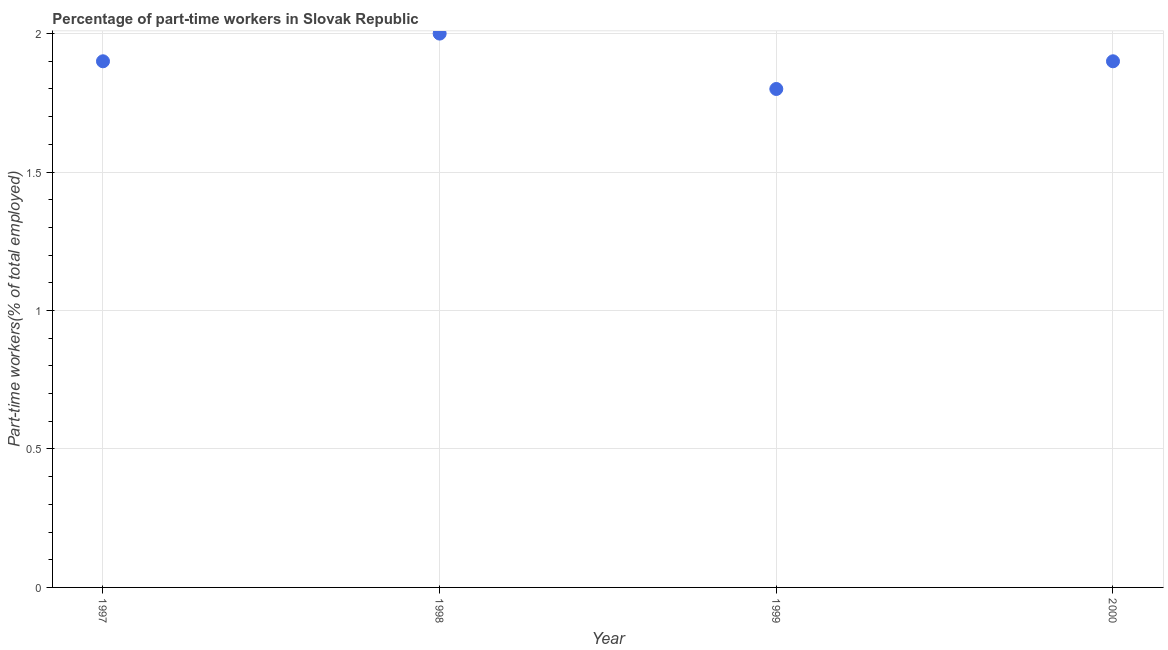What is the percentage of part-time workers in 2000?
Keep it short and to the point. 1.9. Across all years, what is the maximum percentage of part-time workers?
Your answer should be compact. 2. Across all years, what is the minimum percentage of part-time workers?
Your answer should be very brief. 1.8. What is the sum of the percentage of part-time workers?
Your response must be concise. 7.6. What is the difference between the percentage of part-time workers in 1999 and 2000?
Offer a very short reply. -0.1. What is the average percentage of part-time workers per year?
Offer a terse response. 1.9. What is the median percentage of part-time workers?
Your answer should be very brief. 1.9. Do a majority of the years between 1999 and 2000 (inclusive) have percentage of part-time workers greater than 1.2 %?
Offer a terse response. Yes. What is the ratio of the percentage of part-time workers in 1998 to that in 2000?
Make the answer very short. 1.05. Is the percentage of part-time workers in 1997 less than that in 1998?
Your response must be concise. Yes. What is the difference between the highest and the second highest percentage of part-time workers?
Your answer should be very brief. 0.1. What is the difference between the highest and the lowest percentage of part-time workers?
Provide a short and direct response. 0.2. How many dotlines are there?
Your answer should be compact. 1. How many years are there in the graph?
Offer a very short reply. 4. What is the difference between two consecutive major ticks on the Y-axis?
Give a very brief answer. 0.5. Are the values on the major ticks of Y-axis written in scientific E-notation?
Keep it short and to the point. No. What is the title of the graph?
Your answer should be compact. Percentage of part-time workers in Slovak Republic. What is the label or title of the X-axis?
Offer a very short reply. Year. What is the label or title of the Y-axis?
Make the answer very short. Part-time workers(% of total employed). What is the Part-time workers(% of total employed) in 1997?
Your response must be concise. 1.9. What is the Part-time workers(% of total employed) in 1999?
Your answer should be compact. 1.8. What is the Part-time workers(% of total employed) in 2000?
Your answer should be compact. 1.9. What is the difference between the Part-time workers(% of total employed) in 1997 and 1998?
Make the answer very short. -0.1. What is the difference between the Part-time workers(% of total employed) in 1997 and 2000?
Offer a very short reply. 0. What is the difference between the Part-time workers(% of total employed) in 1998 and 1999?
Make the answer very short. 0.2. What is the difference between the Part-time workers(% of total employed) in 1999 and 2000?
Your answer should be very brief. -0.1. What is the ratio of the Part-time workers(% of total employed) in 1997 to that in 1998?
Offer a very short reply. 0.95. What is the ratio of the Part-time workers(% of total employed) in 1997 to that in 1999?
Your response must be concise. 1.06. What is the ratio of the Part-time workers(% of total employed) in 1997 to that in 2000?
Provide a short and direct response. 1. What is the ratio of the Part-time workers(% of total employed) in 1998 to that in 1999?
Offer a very short reply. 1.11. What is the ratio of the Part-time workers(% of total employed) in 1998 to that in 2000?
Provide a succinct answer. 1.05. What is the ratio of the Part-time workers(% of total employed) in 1999 to that in 2000?
Ensure brevity in your answer.  0.95. 